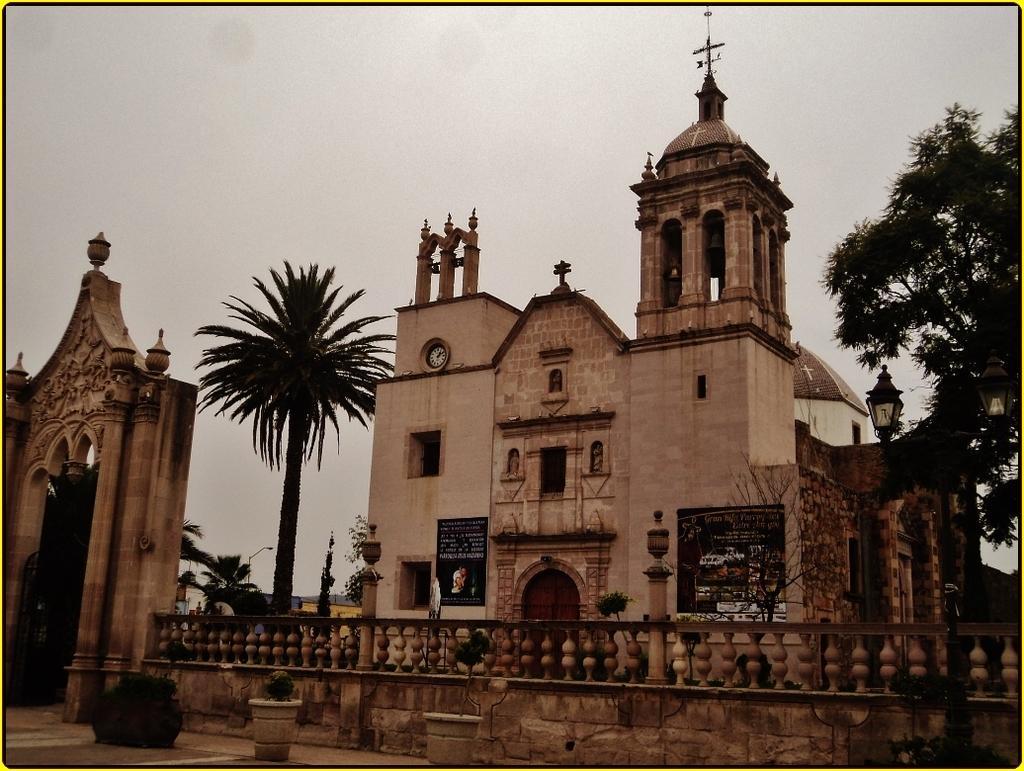Describe this image in one or two sentences. This image consists of a building which is in the center. In front of the building there is a wall and there are pots, plant. On the left side of the building there are trees and there is an arch. On the right side of the building there are poles and a tree and the sky is cloudy. 